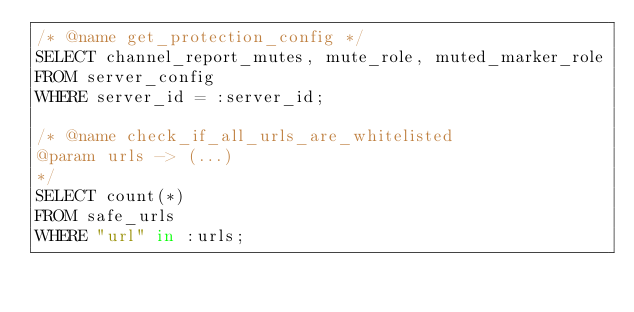<code> <loc_0><loc_0><loc_500><loc_500><_SQL_>/* @name get_protection_config */
SELECT channel_report_mutes, mute_role, muted_marker_role
FROM server_config
WHERE server_id = :server_id;

/* @name check_if_all_urls_are_whitelisted 
@param urls -> (...)
*/
SELECT count(*)
FROM safe_urls
WHERE "url" in :urls;
</code> 